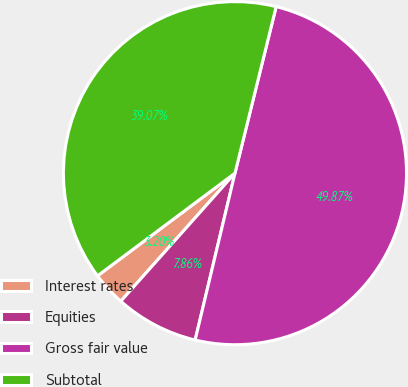<chart> <loc_0><loc_0><loc_500><loc_500><pie_chart><fcel>Interest rates<fcel>Equities<fcel>Gross fair value<fcel>Subtotal<nl><fcel>3.2%<fcel>7.86%<fcel>49.87%<fcel>39.07%<nl></chart> 